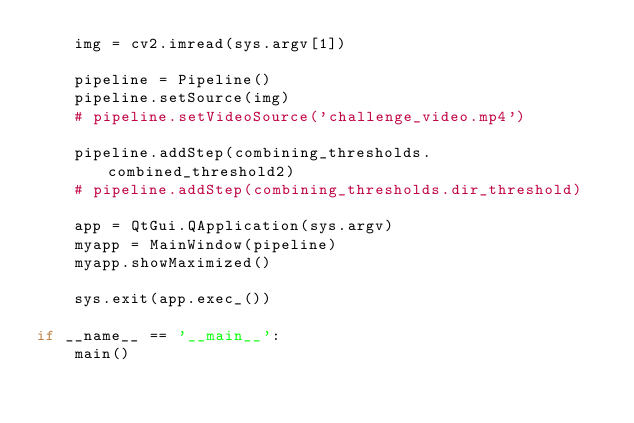<code> <loc_0><loc_0><loc_500><loc_500><_Python_>    img = cv2.imread(sys.argv[1])
    
    pipeline = Pipeline()
    pipeline.setSource(img)
    # pipeline.setVideoSource('challenge_video.mp4')

    pipeline.addStep(combining_thresholds.combined_threshold2)
    # pipeline.addStep(combining_thresholds.dir_threshold)

    app = QtGui.QApplication(sys.argv)
    myapp = MainWindow(pipeline)
    myapp.showMaximized()

    sys.exit(app.exec_())

if __name__ == '__main__':
    main()</code> 